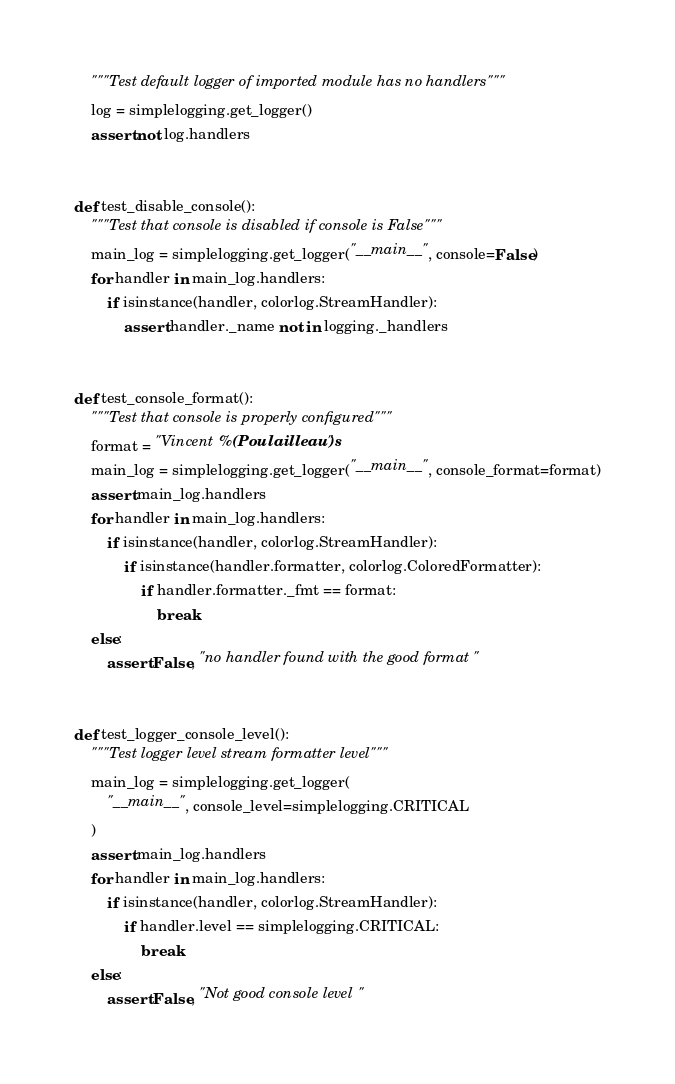<code> <loc_0><loc_0><loc_500><loc_500><_Python_>    """Test default logger of imported module has no handlers"""
    log = simplelogging.get_logger()
    assert not log.handlers


def test_disable_console():
    """Test that console is disabled if console is False"""
    main_log = simplelogging.get_logger("__main__", console=False)
    for handler in main_log.handlers:
        if isinstance(handler, colorlog.StreamHandler):
            assert handler._name not in logging._handlers


def test_console_format():
    """Test that console is properly configured"""
    format = "Vincent %(Poulailleau)s"
    main_log = simplelogging.get_logger("__main__", console_format=format)
    assert main_log.handlers
    for handler in main_log.handlers:
        if isinstance(handler, colorlog.StreamHandler):
            if isinstance(handler.formatter, colorlog.ColoredFormatter):
                if handler.formatter._fmt == format:
                    break
    else:
        assert False, "no handler found with the good format"


def test_logger_console_level():
    """Test logger level stream formatter level"""
    main_log = simplelogging.get_logger(
        "__main__", console_level=simplelogging.CRITICAL
    )
    assert main_log.handlers
    for handler in main_log.handlers:
        if isinstance(handler, colorlog.StreamHandler):
            if handler.level == simplelogging.CRITICAL:
                break
    else:
        assert False, "Not good console level"
</code> 